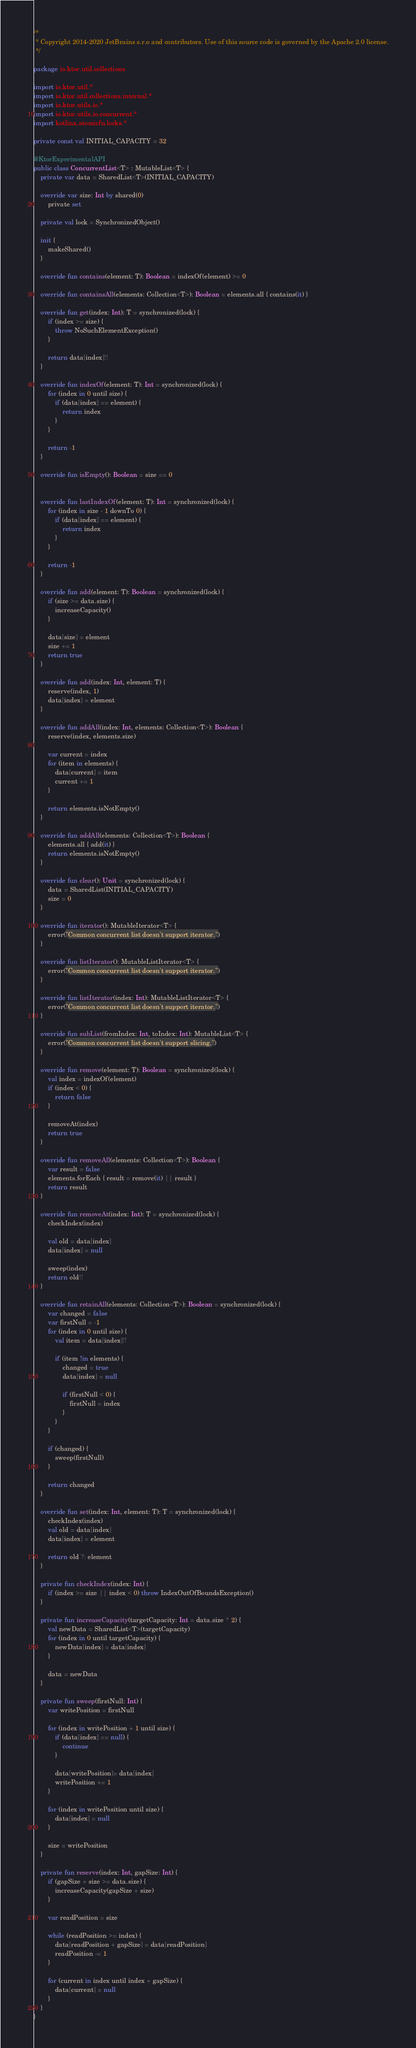<code> <loc_0><loc_0><loc_500><loc_500><_Kotlin_>/*
 * Copyright 2014-2020 JetBrains s.r.o and contributors. Use of this source code is governed by the Apache 2.0 license.
 */

package io.ktor.util.collections

import io.ktor.util.*
import io.ktor.util.collections.internal.*
import io.ktor.utils.io.*
import io.ktor.utils.io.concurrent.*
import kotlinx.atomicfu.locks.*

private const val INITIAL_CAPACITY = 32

@KtorExperimentalAPI
public class ConcurrentList<T> : MutableList<T> {
    private var data = SharedList<T>(INITIAL_CAPACITY)

    override var size: Int by shared(0)
        private set

    private val lock = SynchronizedObject()

    init {
        makeShared()
    }

    override fun contains(element: T): Boolean = indexOf(element) >= 0

    override fun containsAll(elements: Collection<T>): Boolean = elements.all { contains(it) }

    override fun get(index: Int): T = synchronized(lock) {
        if (index >= size) {
            throw NoSuchElementException()
        }

        return data[index]!!
    }

    override fun indexOf(element: T): Int = synchronized(lock) {
        for (index in 0 until size) {
            if (data[index] == element) {
                return index
            }
        }

        return -1
    }

    override fun isEmpty(): Boolean = size == 0


    override fun lastIndexOf(element: T): Int = synchronized(lock) {
        for (index in size - 1 downTo 0) {
            if (data[index] == element) {
                return index
            }
        }

        return -1
    }

    override fun add(element: T): Boolean = synchronized(lock) {
        if (size >= data.size) {
            increaseCapacity()
        }

        data[size] = element
        size += 1
        return true
    }

    override fun add(index: Int, element: T) {
        reserve(index, 1)
        data[index] = element
    }

    override fun addAll(index: Int, elements: Collection<T>): Boolean {
        reserve(index, elements.size)

        var current = index
        for (item in elements) {
            data[current] = item
            current += 1
        }

        return elements.isNotEmpty()
    }

    override fun addAll(elements: Collection<T>): Boolean {
        elements.all { add(it) }
        return elements.isNotEmpty()
    }

    override fun clear(): Unit = synchronized(lock) {
        data = SharedList(INITIAL_CAPACITY)
        size = 0
    }

    override fun iterator(): MutableIterator<T> {
        error("Common concurrent list doesn't support iterator.")
    }

    override fun listIterator(): MutableListIterator<T> {
        error("Common concurrent list doesn't support iterator.")
    }

    override fun listIterator(index: Int): MutableListIterator<T> {
        error("Common concurrent list doesn't support iterator.")
    }

    override fun subList(fromIndex: Int, toIndex: Int): MutableList<T> {
        error("Common concurrent list doesn't support slicing.")
    }

    override fun remove(element: T): Boolean = synchronized(lock) {
        val index = indexOf(element)
        if (index < 0) {
            return false
        }

        removeAt(index)
        return true
    }

    override fun removeAll(elements: Collection<T>): Boolean {
        var result = false
        elements.forEach { result = remove(it) || result }
        return result
    }

    override fun removeAt(index: Int): T = synchronized(lock) {
        checkIndex(index)

        val old = data[index]
        data[index] = null

        sweep(index)
        return old!!
    }

    override fun retainAll(elements: Collection<T>): Boolean = synchronized(lock) {
        var changed = false
        var firstNull = -1
        for (index in 0 until size) {
            val item = data[index]!!

            if (item !in elements) {
                changed = true
                data[index] = null

                if (firstNull < 0) {
                    firstNull = index
                }
            }
        }

        if (changed) {
            sweep(firstNull)
        }

        return changed
    }

    override fun set(index: Int, element: T): T = synchronized(lock) {
        checkIndex(index)
        val old = data[index]
        data[index] = element

        return old ?: element
    }

    private fun checkIndex(index: Int) {
        if (index >= size || index < 0) throw IndexOutOfBoundsException()
    }

    private fun increaseCapacity(targetCapacity: Int = data.size * 2) {
        val newData = SharedList<T>(targetCapacity)
        for (index in 0 until targetCapacity) {
            newData[index] = data[index]
        }

        data = newData
    }

    private fun sweep(firstNull: Int) {
        var writePosition = firstNull

        for (index in writePosition + 1 until size) {
            if (data[index] == null) {
                continue
            }

            data[writePosition]= data[index]
            writePosition += 1
        }

        for (index in writePosition until size) {
            data[index] = null
        }

        size = writePosition
    }

    private fun reserve(index: Int, gapSize: Int) {
        if (gapSize + size >= data.size) {
            increaseCapacity(gapSize + size)
        }

        var readPosition = size

        while (readPosition >= index) {
            data[readPosition + gapSize] = data[readPosition]
            readPosition -= 1
        }

        for (current in index until index + gapSize) {
            data[current] = null
        }
    }
}

</code> 